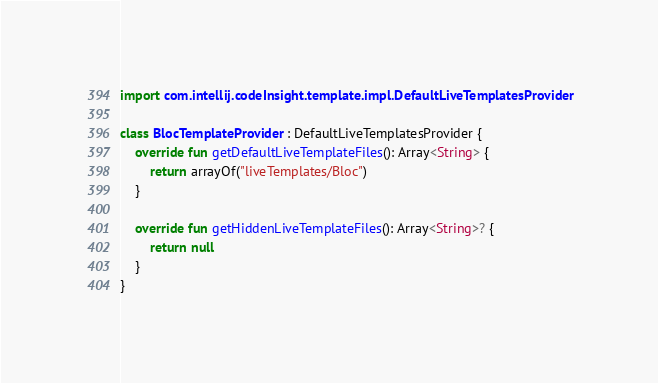Convert code to text. <code><loc_0><loc_0><loc_500><loc_500><_Kotlin_>
import com.intellij.codeInsight.template.impl.DefaultLiveTemplatesProvider

class BlocTemplateProvider : DefaultLiveTemplatesProvider {
    override fun getDefaultLiveTemplateFiles(): Array<String> {
        return arrayOf("liveTemplates/Bloc")
    }

    override fun getHiddenLiveTemplateFiles(): Array<String>? {
        return null
    }
}</code> 